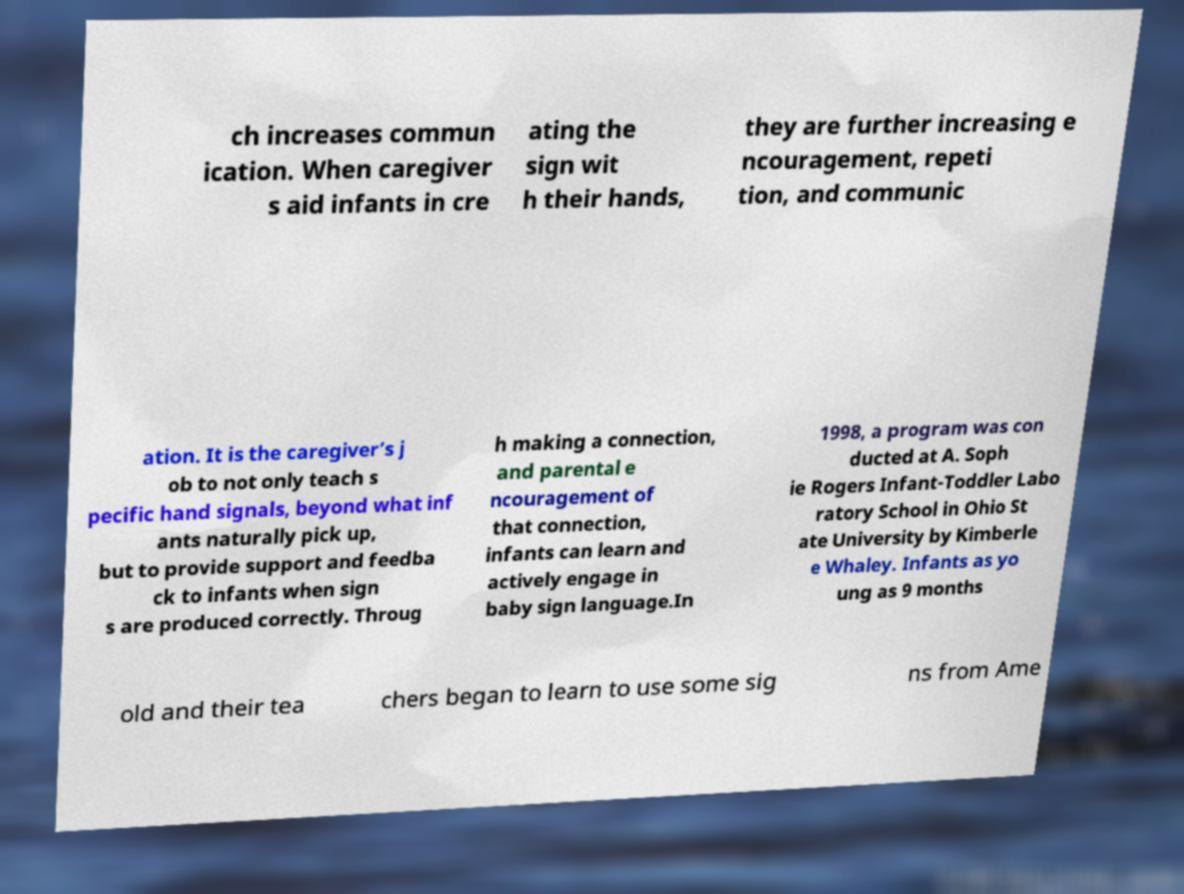Can you accurately transcribe the text from the provided image for me? ch increases commun ication. When caregiver s aid infants in cre ating the sign wit h their hands, they are further increasing e ncouragement, repeti tion, and communic ation. It is the caregiver’s j ob to not only teach s pecific hand signals, beyond what inf ants naturally pick up, but to provide support and feedba ck to infants when sign s are produced correctly. Throug h making a connection, and parental e ncouragement of that connection, infants can learn and actively engage in baby sign language.In 1998, a program was con ducted at A. Soph ie Rogers Infant-Toddler Labo ratory School in Ohio St ate University by Kimberle e Whaley. Infants as yo ung as 9 months old and their tea chers began to learn to use some sig ns from Ame 